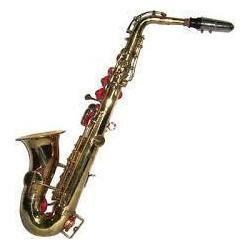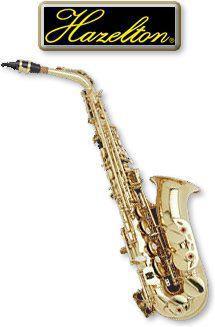The first image is the image on the left, the second image is the image on the right. Examine the images to the left and right. Is the description "Both images contain a saxophone that is a blue or purple non-traditional color and all saxophones on the right have the bell facing upwards." accurate? Answer yes or no. No. The first image is the image on the left, the second image is the image on the right. Examine the images to the left and right. Is the description "Both of the saxophone bodies share the same rich color, and it is not a traditional metallic (silver or gold) color." accurate? Answer yes or no. No. 